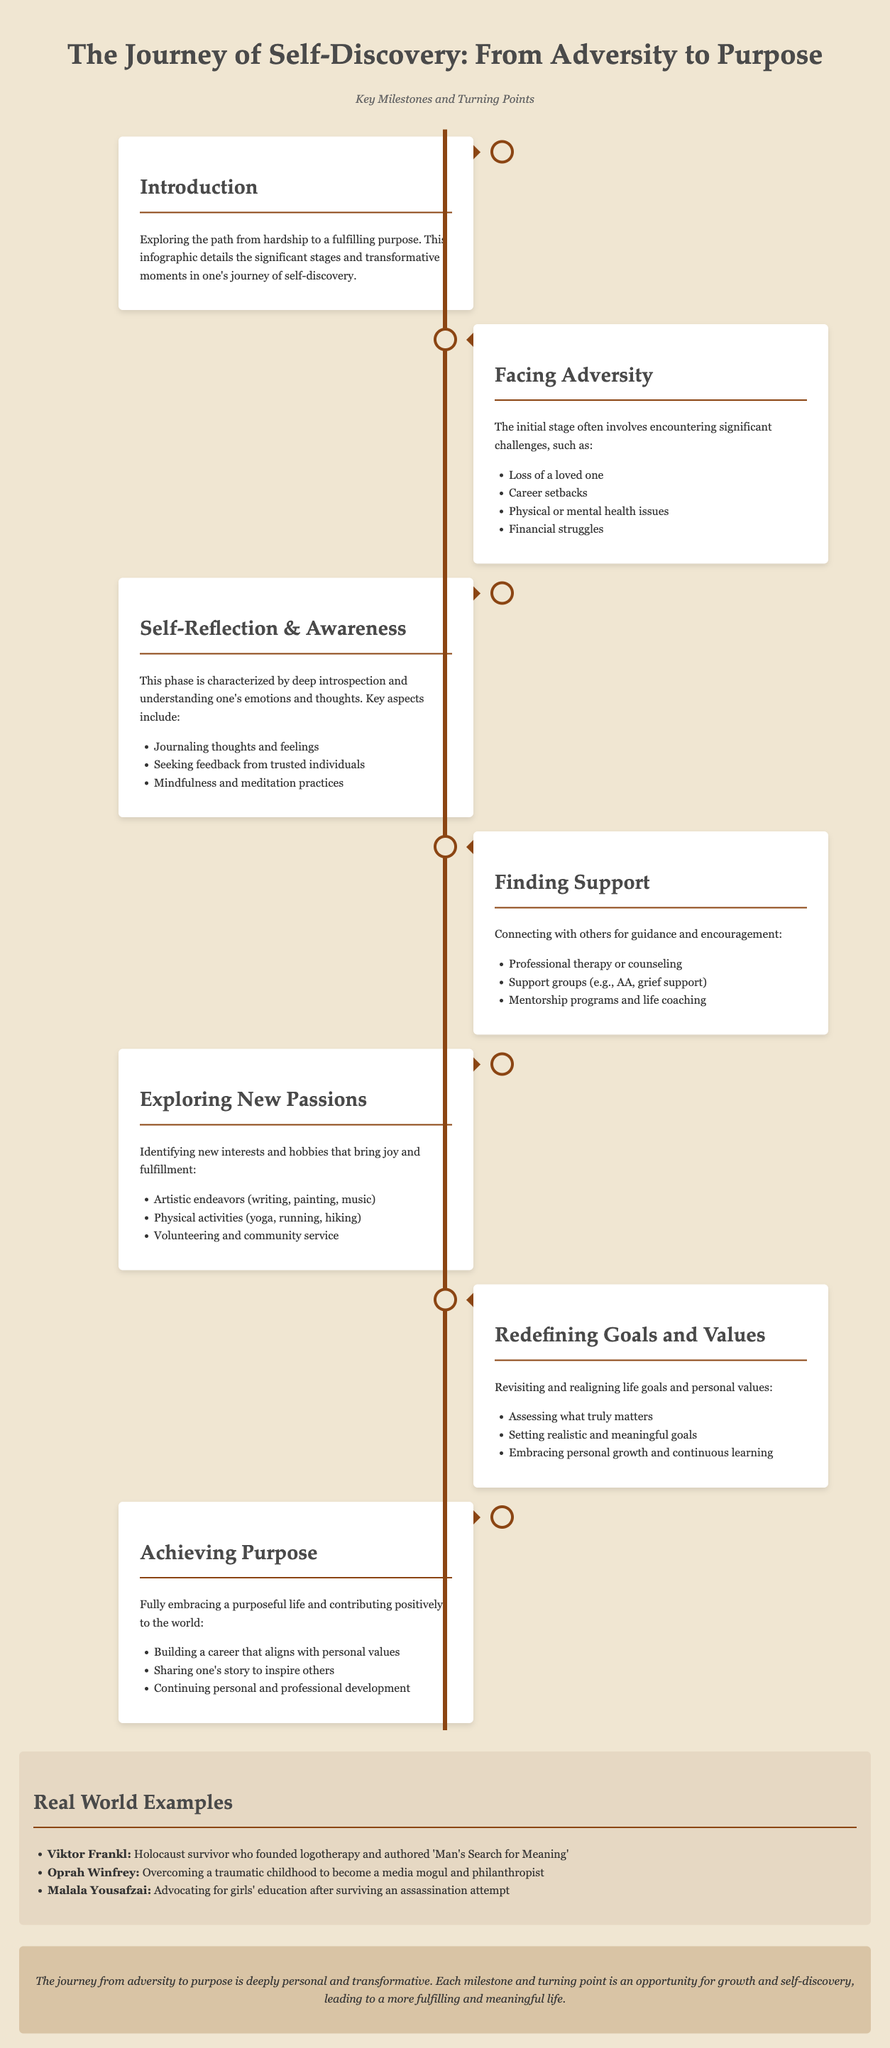What is the title of the infographic? The title of the infographic is stated at the top of the document, introducing the main theme of the content.
Answer: The Journey of Self-Discovery: From Adversity to Purpose What is the first milestone mentioned in the infographic? The first milestone illustrates the initial step in the process of self-discovery, detailing the significant challenges that are faced.
Answer: Facing Adversity Name one example of adversity listed in the document. The document provides specific examples of adversities that individuals may encounter, listed under the 'Facing Adversity' section.
Answer: Loss of a loved one What practice is suggested for self-reflection and awareness? The infographic outlines practices that contribute to self-awareness, particularly emphasizing introspection.
Answer: Journaling thoughts and feelings Which well-known individual is mentioned as a real-world example? One notable figure is highlighted in the examples section, illustrating a successful journey from adversity to purpose.
Answer: Viktor Frankl How many stages and transformative moments does the infographic detail? The infographic presents a structured timeline with several key milestones that individuals may experience in their journey.
Answer: Six What is the final goal of the journey depicted in the infographic? The last milestone describes the ultimate aim that individuals strive for after overcoming obstacles and self-reflection.
Answer: Achieving Purpose What color is used for the timelines in the infographic? The colors used for the timeline are referenced in the styles and descriptions within the document.
Answer: Brown What is a key aspect of redefining goals and values? The infographic lists important components that contribute to rediscovering one's purpose, particularly focusing on life goals.
Answer: Assessing what truly matters 